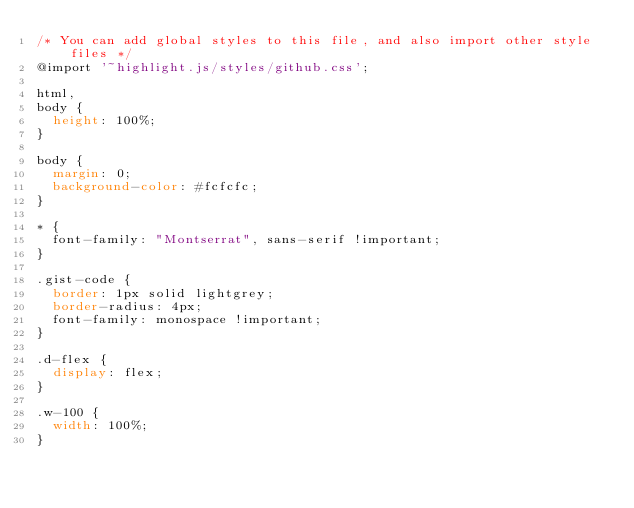Convert code to text. <code><loc_0><loc_0><loc_500><loc_500><_CSS_>/* You can add global styles to this file, and also import other style files */
@import '~highlight.js/styles/github.css';

html,
body {
  height: 100%;
}

body {
  margin: 0;
  background-color: #fcfcfc;
}

* {
  font-family: "Montserrat", sans-serif !important;
}

.gist-code {
  border: 1px solid lightgrey;
  border-radius: 4px;
  font-family: monospace !important;
}

.d-flex {
  display: flex;
}

.w-100 {
  width: 100%;
}
</code> 